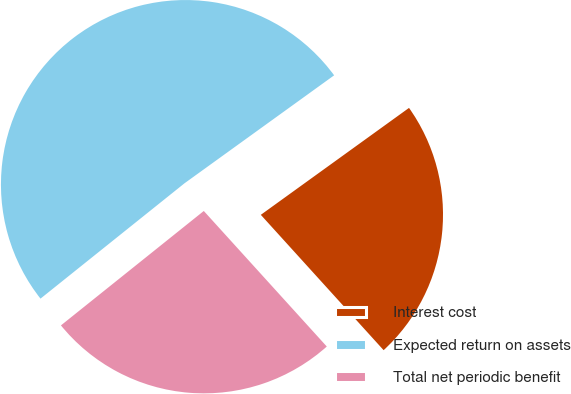<chart> <loc_0><loc_0><loc_500><loc_500><pie_chart><fcel>Interest cost<fcel>Expected return on assets<fcel>Total net periodic benefit<nl><fcel>23.22%<fcel>50.8%<fcel>25.98%<nl></chart> 